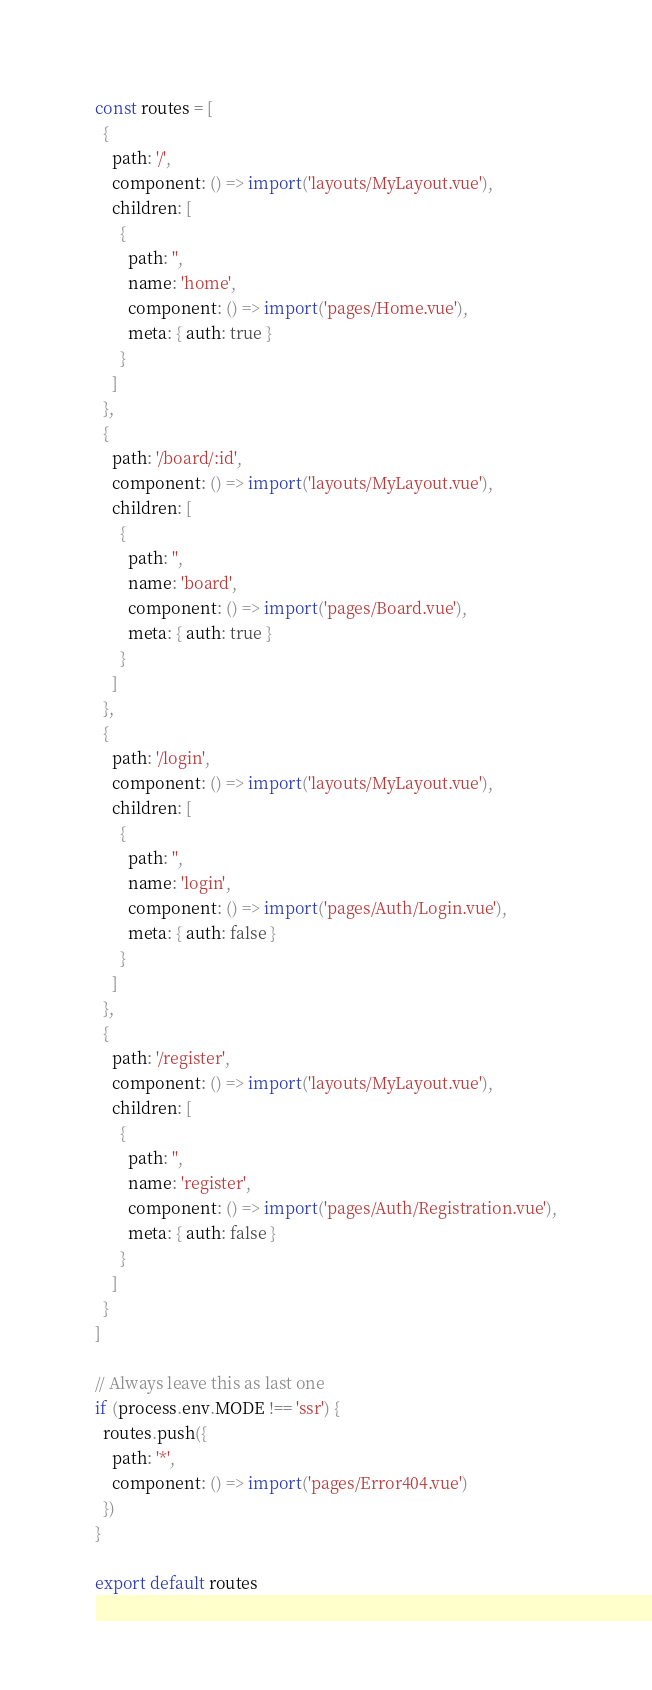<code> <loc_0><loc_0><loc_500><loc_500><_JavaScript_>
const routes = [
  {
    path: '/',
    component: () => import('layouts/MyLayout.vue'),
    children: [
      {
        path: '',
        name: 'home',
        component: () => import('pages/Home.vue'),
        meta: { auth: true }
      }
    ]
  },
  {
    path: '/board/:id',
    component: () => import('layouts/MyLayout.vue'),
    children: [
      {
        path: '',
        name: 'board',
        component: () => import('pages/Board.vue'),
        meta: { auth: true }
      }
    ]
  },
  {
    path: '/login',
    component: () => import('layouts/MyLayout.vue'),
    children: [
      {
        path: '',
        name: 'login',
        component: () => import('pages/Auth/Login.vue'),
        meta: { auth: false }
      }
    ]
  },
  {
    path: '/register',
    component: () => import('layouts/MyLayout.vue'),
    children: [
      {
        path: '',
        name: 'register',
        component: () => import('pages/Auth/Registration.vue'),
        meta: { auth: false }
      }
    ]
  }
]

// Always leave this as last one
if (process.env.MODE !== 'ssr') {
  routes.push({
    path: '*',
    component: () => import('pages/Error404.vue')
  })
}

export default routes
</code> 